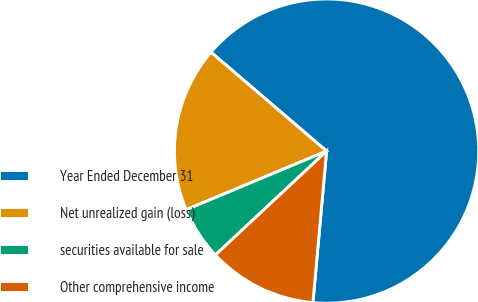Convert chart. <chart><loc_0><loc_0><loc_500><loc_500><pie_chart><fcel>Year Ended December 31<fcel>Net unrealized gain (loss)<fcel>securities available for sale<fcel>Other comprehensive income<nl><fcel>65.16%<fcel>17.56%<fcel>5.66%<fcel>11.61%<nl></chart> 